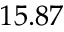<formula> <loc_0><loc_0><loc_500><loc_500>1 5 . 8 7</formula> 